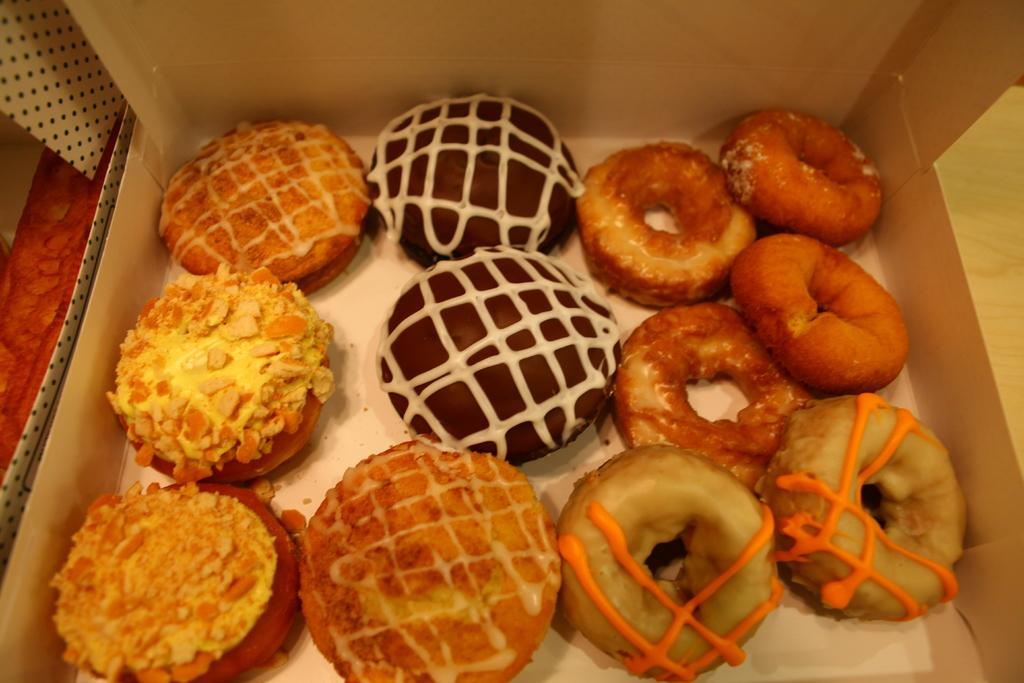What is the material of the box in the image? The box is made of cardboard. What is inside the box? The box contains different food items. Where is the box located in the image? The box is placed on a table. What type of leather is visible on the table in the image? There is no leather visible on the table in the image. What activity is taking place with the food items in the box? The image does not show any activity involving the food items in the box. 